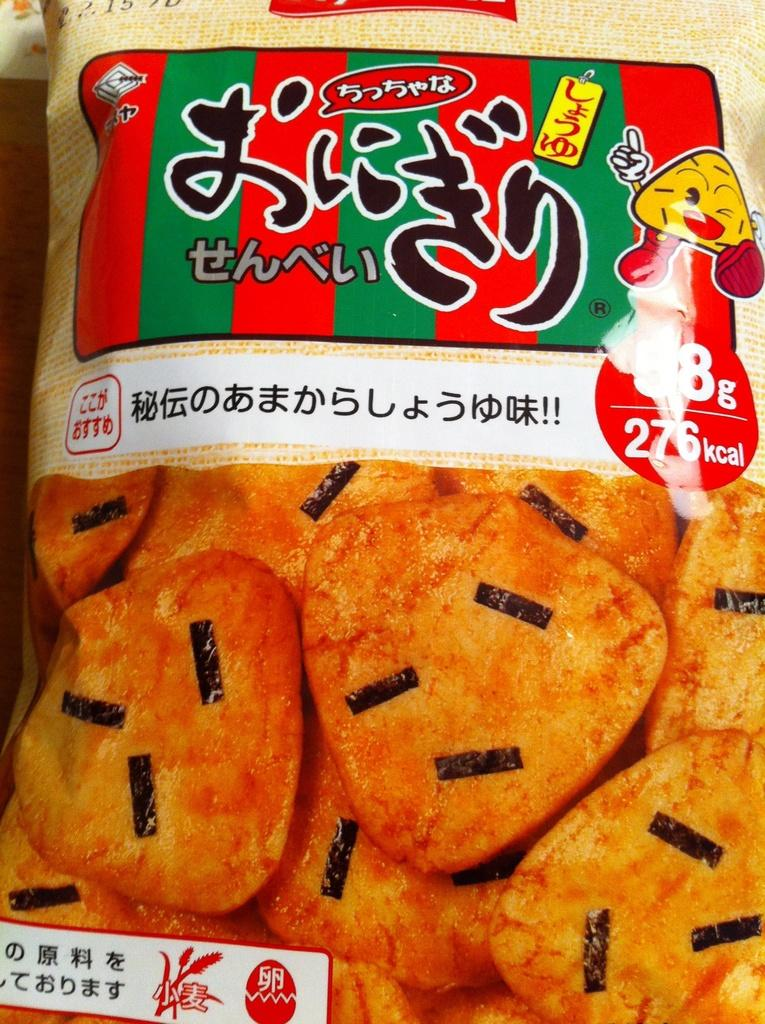What is present in the image? There is a packet in the image. What can be seen on the packet? The packet has an image of a food item on it. Are there any words on the packet? Yes, there is text on the packet. How many family members are shown enjoying the meal in the image? There are no family members or meal depicted in the image; it only features a packet with an image of a food item and text. 